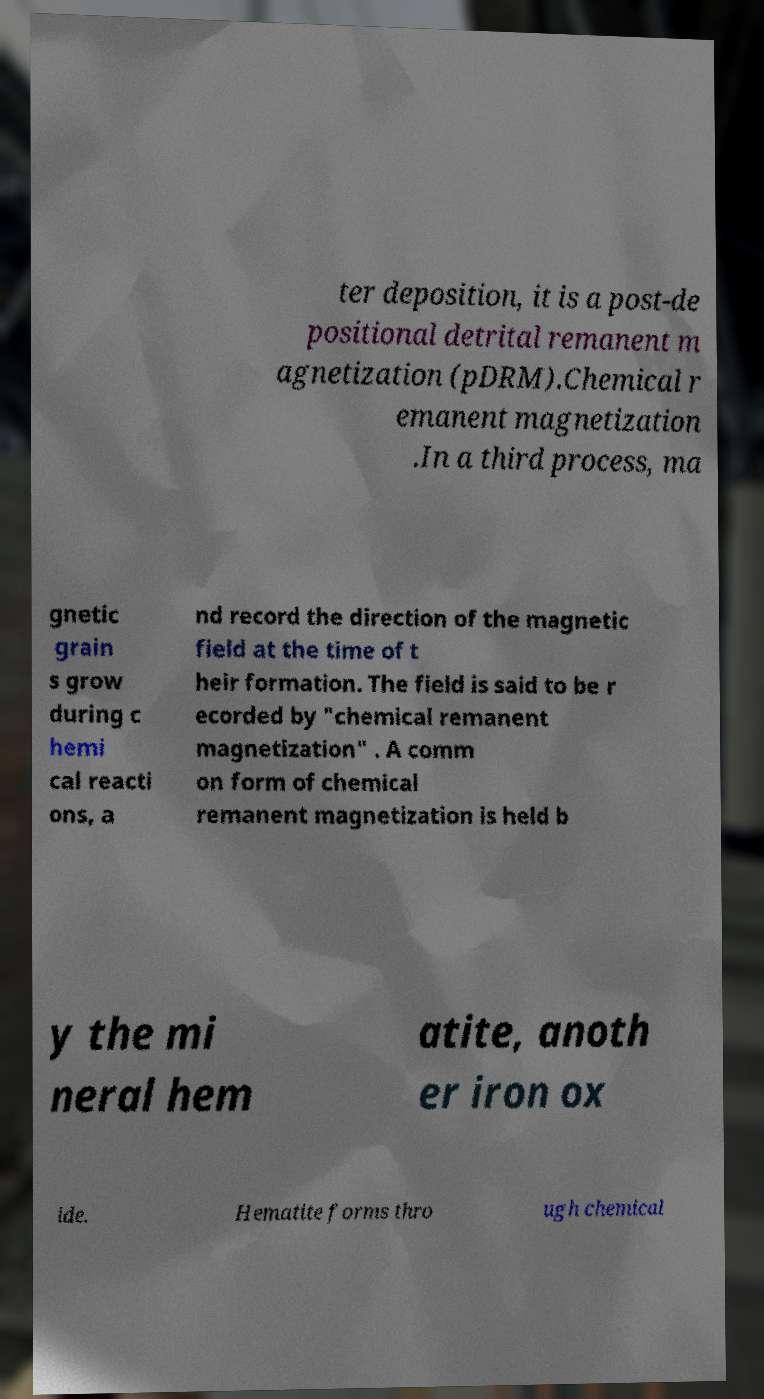I need the written content from this picture converted into text. Can you do that? ter deposition, it is a post-de positional detrital remanent m agnetization (pDRM).Chemical r emanent magnetization .In a third process, ma gnetic grain s grow during c hemi cal reacti ons, a nd record the direction of the magnetic field at the time of t heir formation. The field is said to be r ecorded by "chemical remanent magnetization" . A comm on form of chemical remanent magnetization is held b y the mi neral hem atite, anoth er iron ox ide. Hematite forms thro ugh chemical 